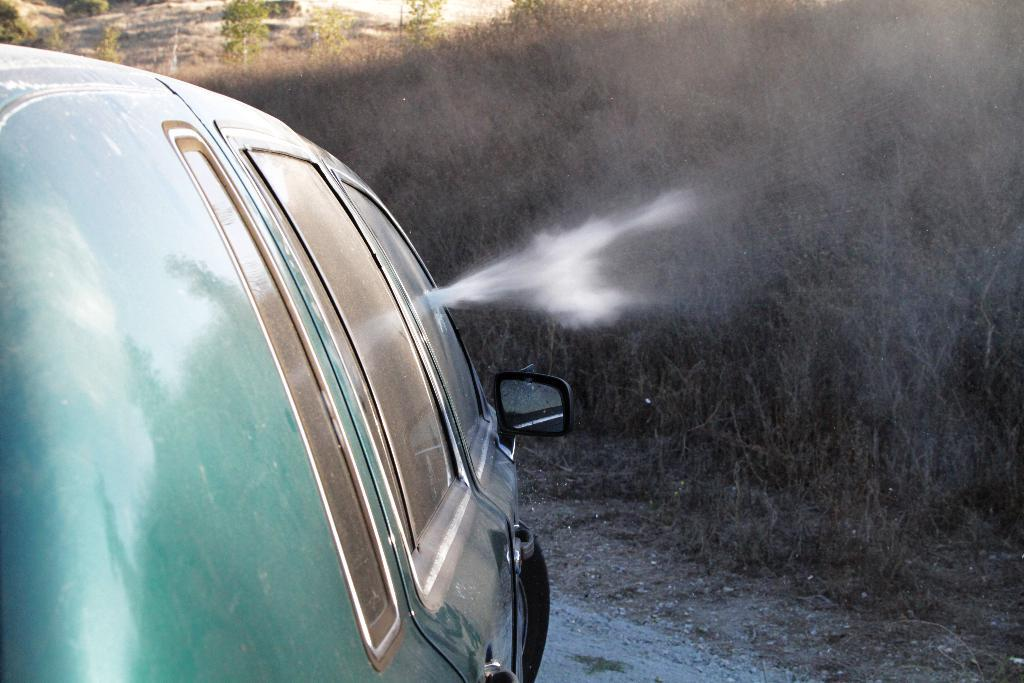What is the main subject of the image? The main subject of the image is a car. Where is the car located in the image? The car is on the ground in the image. What type of windows does the car have? The car has glass windows. What additional feature can be seen on the car? The car has a mirror. What can be seen behind the car in the image? There are plants behind the car. What type of quince is being used to polish the car in the image? There is no quince present in the image, and the car is not being polished. How many appliances are visible in the image? There are no appliances visible in the image; it features a car with its specific features and the surrounding plants. 